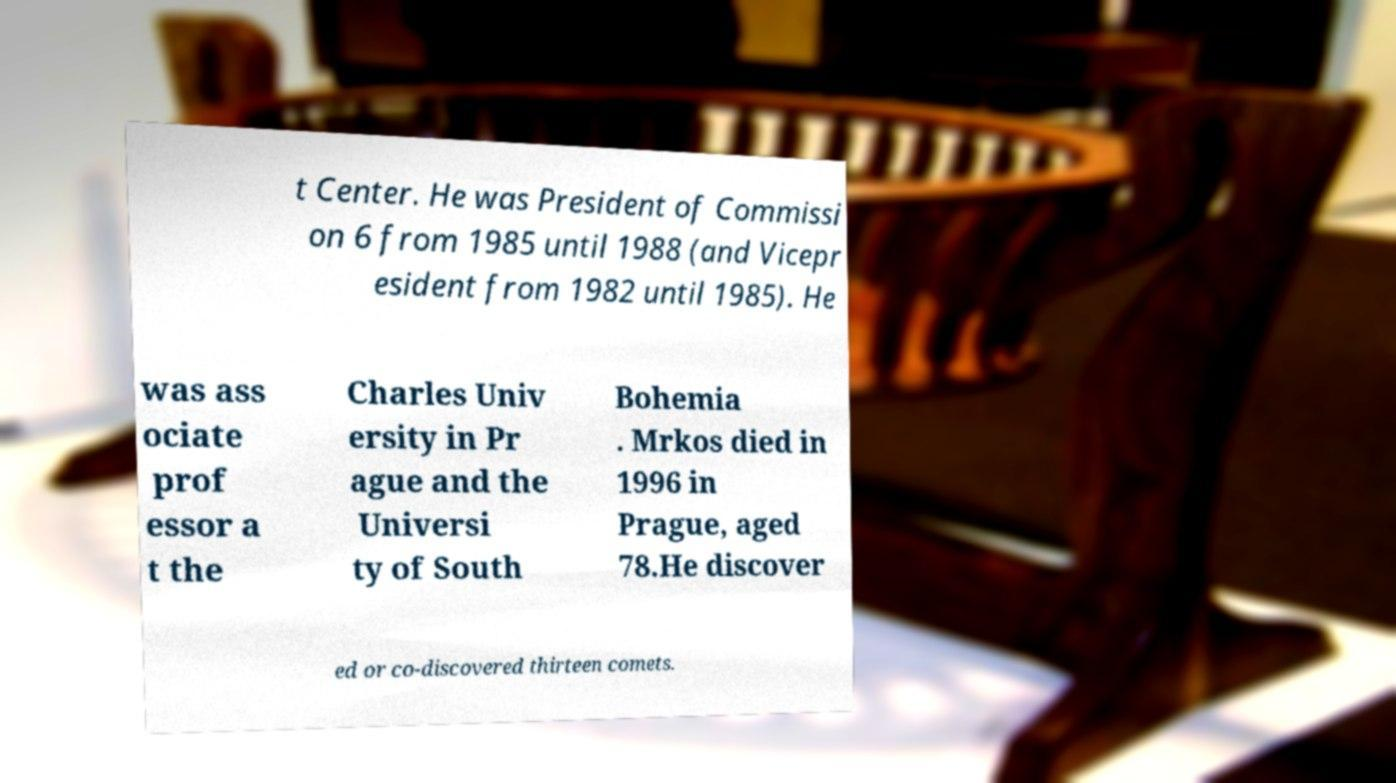I need the written content from this picture converted into text. Can you do that? t Center. He was President of Commissi on 6 from 1985 until 1988 (and Vicepr esident from 1982 until 1985). He was ass ociate prof essor a t the Charles Univ ersity in Pr ague and the Universi ty of South Bohemia . Mrkos died in 1996 in Prague, aged 78.He discover ed or co-discovered thirteen comets. 